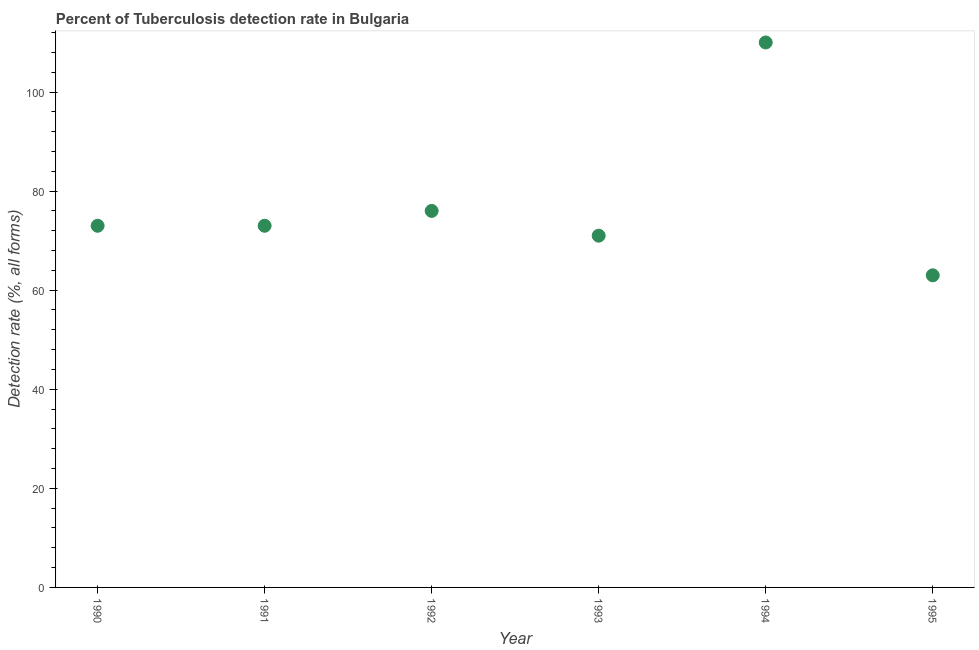What is the detection rate of tuberculosis in 1990?
Give a very brief answer. 73. Across all years, what is the maximum detection rate of tuberculosis?
Give a very brief answer. 110. Across all years, what is the minimum detection rate of tuberculosis?
Your response must be concise. 63. What is the sum of the detection rate of tuberculosis?
Provide a short and direct response. 466. What is the difference between the detection rate of tuberculosis in 1992 and 1993?
Your answer should be very brief. 5. What is the average detection rate of tuberculosis per year?
Provide a succinct answer. 77.67. What is the ratio of the detection rate of tuberculosis in 1990 to that in 1993?
Provide a succinct answer. 1.03. What is the difference between the highest and the second highest detection rate of tuberculosis?
Make the answer very short. 34. Is the sum of the detection rate of tuberculosis in 1990 and 1993 greater than the maximum detection rate of tuberculosis across all years?
Your answer should be very brief. Yes. What is the difference between the highest and the lowest detection rate of tuberculosis?
Your response must be concise. 47. Does the detection rate of tuberculosis monotonically increase over the years?
Your answer should be compact. No. How many dotlines are there?
Provide a succinct answer. 1. How many years are there in the graph?
Your answer should be very brief. 6. What is the difference between two consecutive major ticks on the Y-axis?
Keep it short and to the point. 20. Are the values on the major ticks of Y-axis written in scientific E-notation?
Your answer should be very brief. No. Does the graph contain any zero values?
Make the answer very short. No. Does the graph contain grids?
Your answer should be very brief. No. What is the title of the graph?
Ensure brevity in your answer.  Percent of Tuberculosis detection rate in Bulgaria. What is the label or title of the Y-axis?
Offer a terse response. Detection rate (%, all forms). What is the Detection rate (%, all forms) in 1991?
Make the answer very short. 73. What is the Detection rate (%, all forms) in 1993?
Your response must be concise. 71. What is the Detection rate (%, all forms) in 1994?
Your answer should be very brief. 110. What is the Detection rate (%, all forms) in 1995?
Give a very brief answer. 63. What is the difference between the Detection rate (%, all forms) in 1990 and 1992?
Ensure brevity in your answer.  -3. What is the difference between the Detection rate (%, all forms) in 1990 and 1993?
Give a very brief answer. 2. What is the difference between the Detection rate (%, all forms) in 1990 and 1994?
Your response must be concise. -37. What is the difference between the Detection rate (%, all forms) in 1990 and 1995?
Offer a very short reply. 10. What is the difference between the Detection rate (%, all forms) in 1991 and 1994?
Your answer should be very brief. -37. What is the difference between the Detection rate (%, all forms) in 1991 and 1995?
Your answer should be compact. 10. What is the difference between the Detection rate (%, all forms) in 1992 and 1993?
Provide a short and direct response. 5. What is the difference between the Detection rate (%, all forms) in 1992 and 1994?
Offer a very short reply. -34. What is the difference between the Detection rate (%, all forms) in 1992 and 1995?
Offer a very short reply. 13. What is the difference between the Detection rate (%, all forms) in 1993 and 1994?
Provide a succinct answer. -39. What is the ratio of the Detection rate (%, all forms) in 1990 to that in 1991?
Give a very brief answer. 1. What is the ratio of the Detection rate (%, all forms) in 1990 to that in 1992?
Offer a very short reply. 0.96. What is the ratio of the Detection rate (%, all forms) in 1990 to that in 1993?
Offer a terse response. 1.03. What is the ratio of the Detection rate (%, all forms) in 1990 to that in 1994?
Provide a short and direct response. 0.66. What is the ratio of the Detection rate (%, all forms) in 1990 to that in 1995?
Offer a very short reply. 1.16. What is the ratio of the Detection rate (%, all forms) in 1991 to that in 1993?
Your response must be concise. 1.03. What is the ratio of the Detection rate (%, all forms) in 1991 to that in 1994?
Keep it short and to the point. 0.66. What is the ratio of the Detection rate (%, all forms) in 1991 to that in 1995?
Give a very brief answer. 1.16. What is the ratio of the Detection rate (%, all forms) in 1992 to that in 1993?
Your answer should be compact. 1.07. What is the ratio of the Detection rate (%, all forms) in 1992 to that in 1994?
Keep it short and to the point. 0.69. What is the ratio of the Detection rate (%, all forms) in 1992 to that in 1995?
Give a very brief answer. 1.21. What is the ratio of the Detection rate (%, all forms) in 1993 to that in 1994?
Make the answer very short. 0.65. What is the ratio of the Detection rate (%, all forms) in 1993 to that in 1995?
Offer a very short reply. 1.13. What is the ratio of the Detection rate (%, all forms) in 1994 to that in 1995?
Provide a succinct answer. 1.75. 